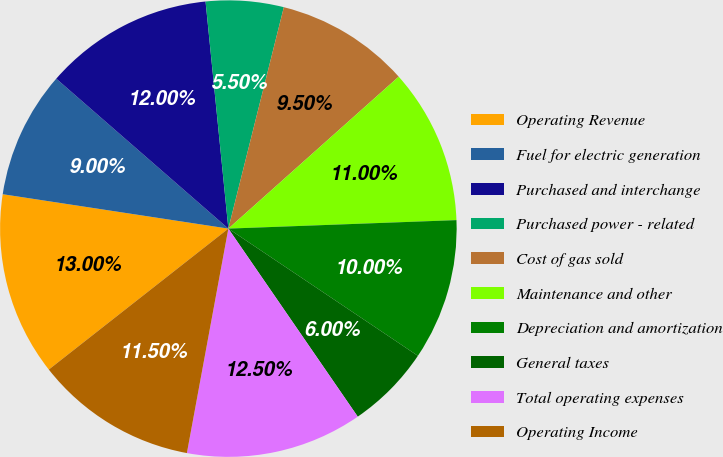Convert chart. <chart><loc_0><loc_0><loc_500><loc_500><pie_chart><fcel>Operating Revenue<fcel>Fuel for electric generation<fcel>Purchased and interchange<fcel>Purchased power - related<fcel>Cost of gas sold<fcel>Maintenance and other<fcel>Depreciation and amortization<fcel>General taxes<fcel>Total operating expenses<fcel>Operating Income<nl><fcel>13.0%<fcel>9.0%<fcel>12.0%<fcel>5.5%<fcel>9.5%<fcel>11.0%<fcel>10.0%<fcel>6.0%<fcel>12.5%<fcel>11.5%<nl></chart> 